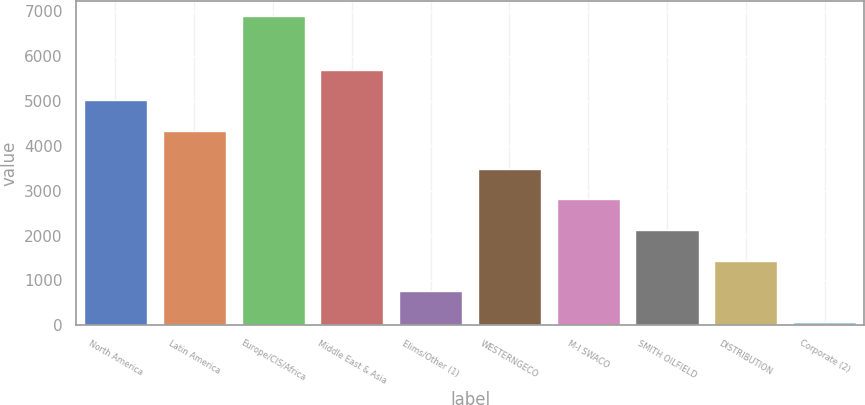<chart> <loc_0><loc_0><loc_500><loc_500><bar_chart><fcel>North America<fcel>Latin America<fcel>Europe/CIS/Africa<fcel>Middle East & Asia<fcel>Elims/Other (1)<fcel>WESTERNGECO<fcel>M-I SWACO<fcel>SMITH OILFIELD<fcel>DISTRIBUTION<fcel>Corporate (2)<nl><fcel>5010<fcel>4321<fcel>6882<fcel>5690<fcel>762<fcel>3482<fcel>2802<fcel>2122<fcel>1442<fcel>82<nl></chart> 